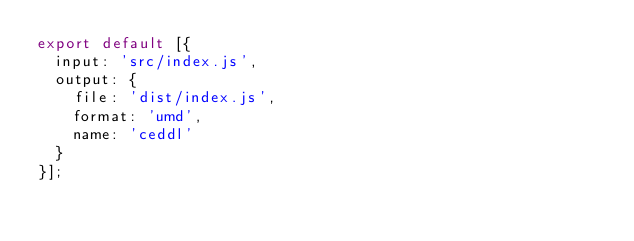Convert code to text. <code><loc_0><loc_0><loc_500><loc_500><_JavaScript_>export default [{
  input: 'src/index.js',
  output: {
    file: 'dist/index.js',
    format: 'umd',
    name: 'ceddl'
  }
}];
</code> 